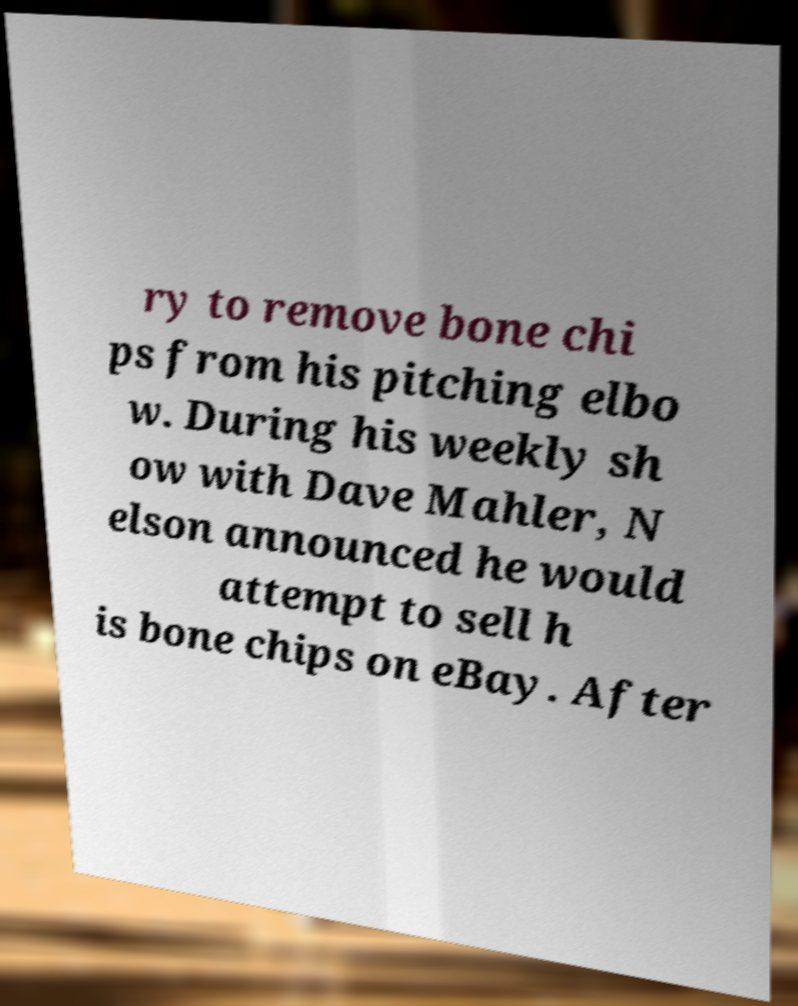There's text embedded in this image that I need extracted. Can you transcribe it verbatim? ry to remove bone chi ps from his pitching elbo w. During his weekly sh ow with Dave Mahler, N elson announced he would attempt to sell h is bone chips on eBay. After 